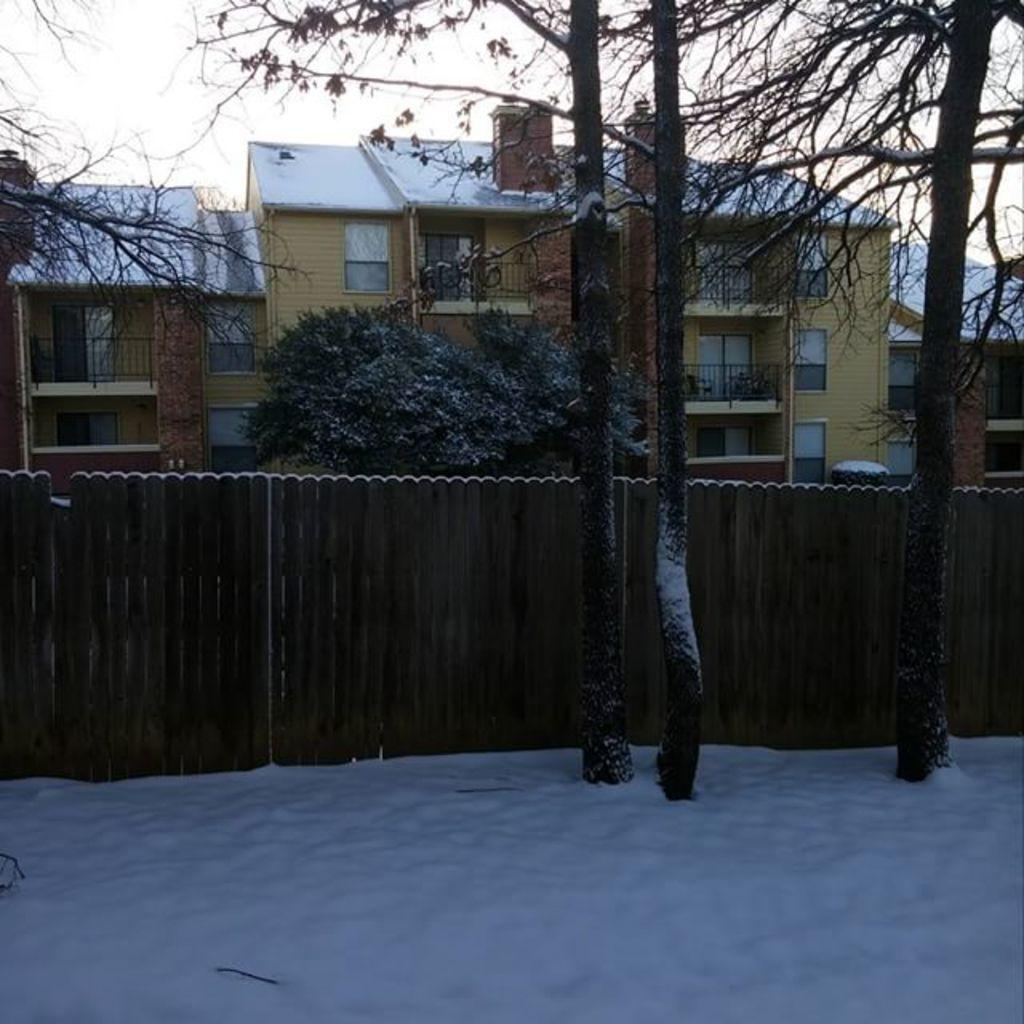What type of structures are visible in the image? There are houses with windows in the image. What other natural elements can be seen in the image? There are trees in the image. What type of barrier is present in the image? There is a wooden fence in the image. What is the condition of the ground in the image? The ground appears to be covered in snow. What is visible in the sky in the image? The sky is visible in the image. What type of rice is being cooked in the image? There is no rice present in the image. How does the friction between the houses and the wooden fence affect the operation of the trees? There is no mention of friction or operation in the image, and trees do not have operations. 